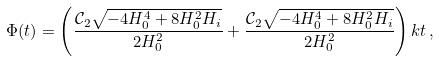<formula> <loc_0><loc_0><loc_500><loc_500>\Phi ( t ) = \left ( \frac { \mathcal { C } _ { 2 } \sqrt { - 4 H _ { 0 } ^ { 4 } + 8 H _ { 0 } ^ { 2 } H _ { i } } } { 2 H _ { 0 } ^ { 2 } } + \frac { \mathcal { C } _ { 2 } \sqrt { - 4 H _ { 0 } ^ { 4 } + 8 H _ { 0 } ^ { 2 } H _ { i } } } { 2 H _ { 0 } ^ { 2 } } \right ) k t \, ,</formula> 